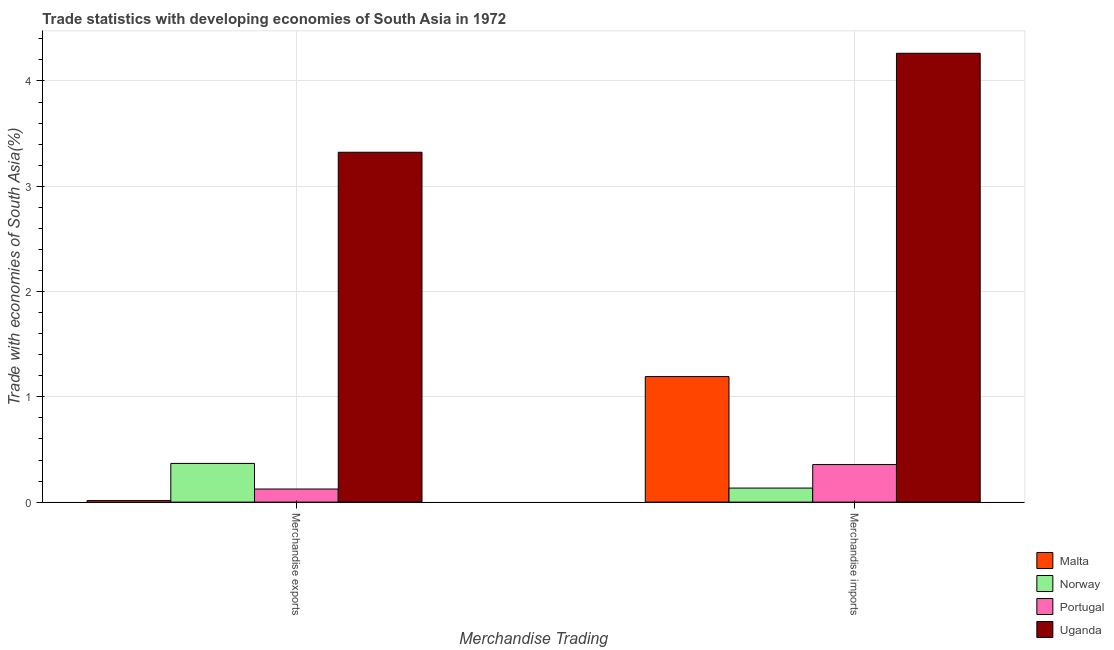Are the number of bars per tick equal to the number of legend labels?
Offer a terse response. Yes. How many bars are there on the 1st tick from the left?
Make the answer very short. 4. What is the label of the 1st group of bars from the left?
Make the answer very short. Merchandise exports. What is the merchandise imports in Uganda?
Keep it short and to the point. 4.26. Across all countries, what is the maximum merchandise exports?
Provide a short and direct response. 3.32. Across all countries, what is the minimum merchandise imports?
Keep it short and to the point. 0.13. In which country was the merchandise imports maximum?
Give a very brief answer. Uganda. In which country was the merchandise imports minimum?
Your response must be concise. Norway. What is the total merchandise imports in the graph?
Your answer should be very brief. 5.95. What is the difference between the merchandise exports in Uganda and that in Malta?
Make the answer very short. 3.31. What is the difference between the merchandise exports in Norway and the merchandise imports in Malta?
Offer a very short reply. -0.82. What is the average merchandise imports per country?
Offer a terse response. 1.49. What is the difference between the merchandise exports and merchandise imports in Norway?
Your answer should be very brief. 0.23. In how many countries, is the merchandise imports greater than 1.6 %?
Give a very brief answer. 1. What is the ratio of the merchandise exports in Portugal to that in Malta?
Make the answer very short. 8.35. What does the 4th bar from the left in Merchandise exports represents?
Your response must be concise. Uganda. What does the 1st bar from the right in Merchandise imports represents?
Keep it short and to the point. Uganda. How many bars are there?
Provide a succinct answer. 8. Are the values on the major ticks of Y-axis written in scientific E-notation?
Provide a short and direct response. No. Does the graph contain grids?
Make the answer very short. Yes. What is the title of the graph?
Your answer should be compact. Trade statistics with developing economies of South Asia in 1972. Does "Bolivia" appear as one of the legend labels in the graph?
Your response must be concise. No. What is the label or title of the X-axis?
Provide a short and direct response. Merchandise Trading. What is the label or title of the Y-axis?
Your response must be concise. Trade with economies of South Asia(%). What is the Trade with economies of South Asia(%) in Malta in Merchandise exports?
Ensure brevity in your answer.  0.01. What is the Trade with economies of South Asia(%) of Norway in Merchandise exports?
Offer a very short reply. 0.37. What is the Trade with economies of South Asia(%) in Portugal in Merchandise exports?
Keep it short and to the point. 0.12. What is the Trade with economies of South Asia(%) in Uganda in Merchandise exports?
Your answer should be compact. 3.32. What is the Trade with economies of South Asia(%) of Malta in Merchandise imports?
Keep it short and to the point. 1.19. What is the Trade with economies of South Asia(%) of Norway in Merchandise imports?
Your answer should be compact. 0.13. What is the Trade with economies of South Asia(%) in Portugal in Merchandise imports?
Make the answer very short. 0.36. What is the Trade with economies of South Asia(%) in Uganda in Merchandise imports?
Provide a short and direct response. 4.26. Across all Merchandise Trading, what is the maximum Trade with economies of South Asia(%) of Malta?
Provide a succinct answer. 1.19. Across all Merchandise Trading, what is the maximum Trade with economies of South Asia(%) of Norway?
Keep it short and to the point. 0.37. Across all Merchandise Trading, what is the maximum Trade with economies of South Asia(%) in Portugal?
Keep it short and to the point. 0.36. Across all Merchandise Trading, what is the maximum Trade with economies of South Asia(%) of Uganda?
Your response must be concise. 4.26. Across all Merchandise Trading, what is the minimum Trade with economies of South Asia(%) of Malta?
Provide a short and direct response. 0.01. Across all Merchandise Trading, what is the minimum Trade with economies of South Asia(%) of Norway?
Offer a terse response. 0.13. Across all Merchandise Trading, what is the minimum Trade with economies of South Asia(%) of Portugal?
Make the answer very short. 0.12. Across all Merchandise Trading, what is the minimum Trade with economies of South Asia(%) in Uganda?
Your response must be concise. 3.32. What is the total Trade with economies of South Asia(%) in Malta in the graph?
Give a very brief answer. 1.21. What is the total Trade with economies of South Asia(%) of Norway in the graph?
Make the answer very short. 0.5. What is the total Trade with economies of South Asia(%) of Portugal in the graph?
Offer a very short reply. 0.48. What is the total Trade with economies of South Asia(%) in Uganda in the graph?
Make the answer very short. 7.59. What is the difference between the Trade with economies of South Asia(%) of Malta in Merchandise exports and that in Merchandise imports?
Give a very brief answer. -1.18. What is the difference between the Trade with economies of South Asia(%) in Norway in Merchandise exports and that in Merchandise imports?
Make the answer very short. 0.23. What is the difference between the Trade with economies of South Asia(%) in Portugal in Merchandise exports and that in Merchandise imports?
Ensure brevity in your answer.  -0.23. What is the difference between the Trade with economies of South Asia(%) in Uganda in Merchandise exports and that in Merchandise imports?
Keep it short and to the point. -0.94. What is the difference between the Trade with economies of South Asia(%) of Malta in Merchandise exports and the Trade with economies of South Asia(%) of Norway in Merchandise imports?
Make the answer very short. -0.12. What is the difference between the Trade with economies of South Asia(%) of Malta in Merchandise exports and the Trade with economies of South Asia(%) of Portugal in Merchandise imports?
Provide a short and direct response. -0.34. What is the difference between the Trade with economies of South Asia(%) in Malta in Merchandise exports and the Trade with economies of South Asia(%) in Uganda in Merchandise imports?
Provide a short and direct response. -4.25. What is the difference between the Trade with economies of South Asia(%) in Norway in Merchandise exports and the Trade with economies of South Asia(%) in Portugal in Merchandise imports?
Ensure brevity in your answer.  0.01. What is the difference between the Trade with economies of South Asia(%) in Norway in Merchandise exports and the Trade with economies of South Asia(%) in Uganda in Merchandise imports?
Provide a succinct answer. -3.9. What is the difference between the Trade with economies of South Asia(%) of Portugal in Merchandise exports and the Trade with economies of South Asia(%) of Uganda in Merchandise imports?
Your answer should be compact. -4.14. What is the average Trade with economies of South Asia(%) of Malta per Merchandise Trading?
Offer a terse response. 0.6. What is the average Trade with economies of South Asia(%) of Norway per Merchandise Trading?
Give a very brief answer. 0.25. What is the average Trade with economies of South Asia(%) of Portugal per Merchandise Trading?
Your answer should be compact. 0.24. What is the average Trade with economies of South Asia(%) in Uganda per Merchandise Trading?
Make the answer very short. 3.79. What is the difference between the Trade with economies of South Asia(%) of Malta and Trade with economies of South Asia(%) of Norway in Merchandise exports?
Your answer should be compact. -0.35. What is the difference between the Trade with economies of South Asia(%) in Malta and Trade with economies of South Asia(%) in Portugal in Merchandise exports?
Your answer should be very brief. -0.11. What is the difference between the Trade with economies of South Asia(%) of Malta and Trade with economies of South Asia(%) of Uganda in Merchandise exports?
Offer a very short reply. -3.31. What is the difference between the Trade with economies of South Asia(%) of Norway and Trade with economies of South Asia(%) of Portugal in Merchandise exports?
Offer a very short reply. 0.24. What is the difference between the Trade with economies of South Asia(%) in Norway and Trade with economies of South Asia(%) in Uganda in Merchandise exports?
Provide a short and direct response. -2.96. What is the difference between the Trade with economies of South Asia(%) in Portugal and Trade with economies of South Asia(%) in Uganda in Merchandise exports?
Your answer should be compact. -3.2. What is the difference between the Trade with economies of South Asia(%) in Malta and Trade with economies of South Asia(%) in Norway in Merchandise imports?
Offer a very short reply. 1.06. What is the difference between the Trade with economies of South Asia(%) in Malta and Trade with economies of South Asia(%) in Portugal in Merchandise imports?
Give a very brief answer. 0.84. What is the difference between the Trade with economies of South Asia(%) in Malta and Trade with economies of South Asia(%) in Uganda in Merchandise imports?
Provide a short and direct response. -3.07. What is the difference between the Trade with economies of South Asia(%) of Norway and Trade with economies of South Asia(%) of Portugal in Merchandise imports?
Make the answer very short. -0.22. What is the difference between the Trade with economies of South Asia(%) in Norway and Trade with economies of South Asia(%) in Uganda in Merchandise imports?
Keep it short and to the point. -4.13. What is the difference between the Trade with economies of South Asia(%) of Portugal and Trade with economies of South Asia(%) of Uganda in Merchandise imports?
Offer a very short reply. -3.91. What is the ratio of the Trade with economies of South Asia(%) of Malta in Merchandise exports to that in Merchandise imports?
Provide a succinct answer. 0.01. What is the ratio of the Trade with economies of South Asia(%) in Norway in Merchandise exports to that in Merchandise imports?
Provide a short and direct response. 2.75. What is the ratio of the Trade with economies of South Asia(%) of Portugal in Merchandise exports to that in Merchandise imports?
Your answer should be compact. 0.35. What is the ratio of the Trade with economies of South Asia(%) of Uganda in Merchandise exports to that in Merchandise imports?
Your answer should be compact. 0.78. What is the difference between the highest and the second highest Trade with economies of South Asia(%) of Malta?
Your answer should be very brief. 1.18. What is the difference between the highest and the second highest Trade with economies of South Asia(%) of Norway?
Offer a very short reply. 0.23. What is the difference between the highest and the second highest Trade with economies of South Asia(%) in Portugal?
Your answer should be compact. 0.23. What is the difference between the highest and the second highest Trade with economies of South Asia(%) in Uganda?
Offer a terse response. 0.94. What is the difference between the highest and the lowest Trade with economies of South Asia(%) of Malta?
Your response must be concise. 1.18. What is the difference between the highest and the lowest Trade with economies of South Asia(%) in Norway?
Your answer should be very brief. 0.23. What is the difference between the highest and the lowest Trade with economies of South Asia(%) in Portugal?
Ensure brevity in your answer.  0.23. What is the difference between the highest and the lowest Trade with economies of South Asia(%) of Uganda?
Keep it short and to the point. 0.94. 